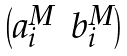Convert formula to latex. <formula><loc_0><loc_0><loc_500><loc_500>\begin{pmatrix} a ^ { M } _ { i } & b ^ { M } _ { i } \end{pmatrix}</formula> 